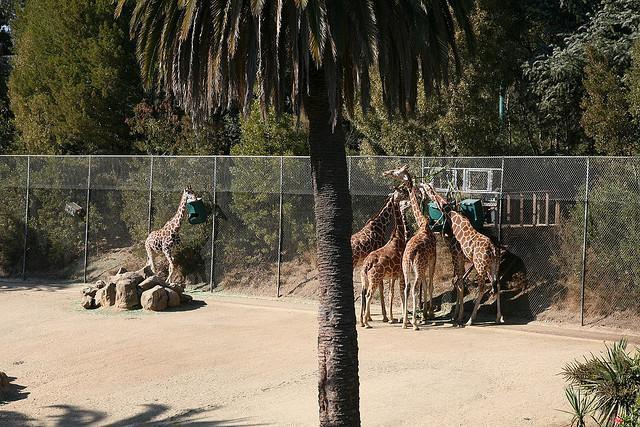How many giraffes?
Give a very brief answer. 5. How many giraffes are here?
Give a very brief answer. 5. How many giraffes are there?
Give a very brief answer. 3. 